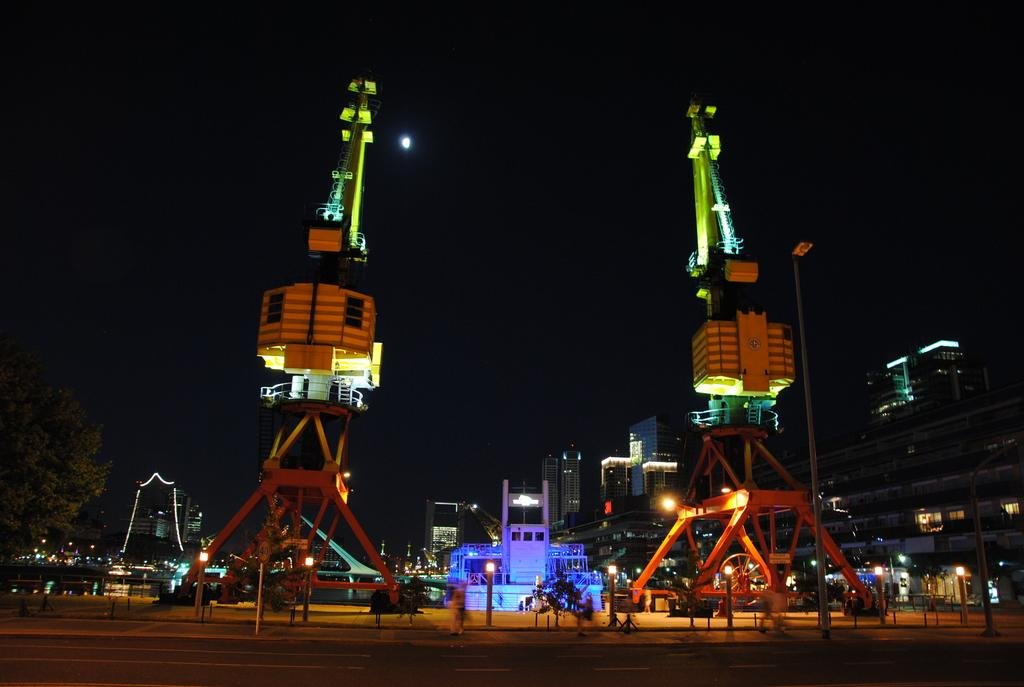What can be seen on either side of the image? There are two constructions on either side of the image. What feature is present above the constructions? Lights are present over the constructions. When was the image taken? The image was taken at night. What can be seen in the background of the image? There are buildings visible in the background of the image. What part of the natural environment is visible in the image? The sky is visible in the image. What type of steel is used to construct the buildings in the image? There is no information about the type of steel used in the construction of the buildings in the image. 